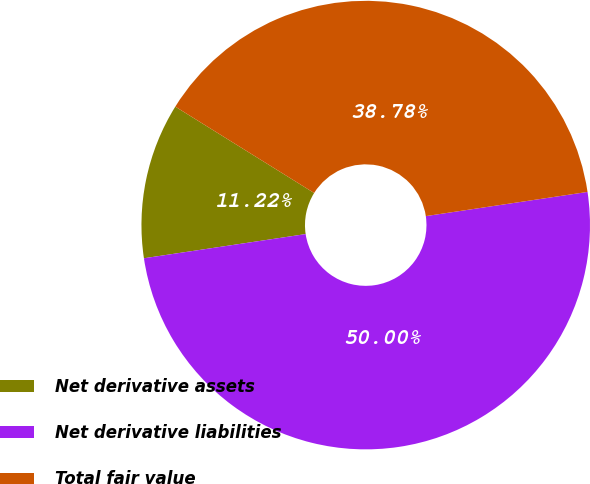<chart> <loc_0><loc_0><loc_500><loc_500><pie_chart><fcel>Net derivative assets<fcel>Net derivative liabilities<fcel>Total fair value<nl><fcel>11.22%<fcel>50.0%<fcel>38.78%<nl></chart> 